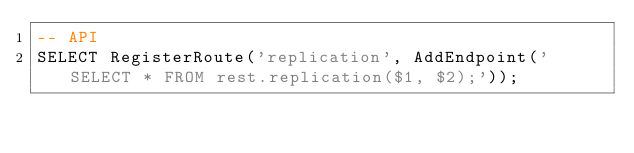<code> <loc_0><loc_0><loc_500><loc_500><_SQL_>-- API
SELECT RegisterRoute('replication', AddEndpoint('SELECT * FROM rest.replication($1, $2);'));
</code> 